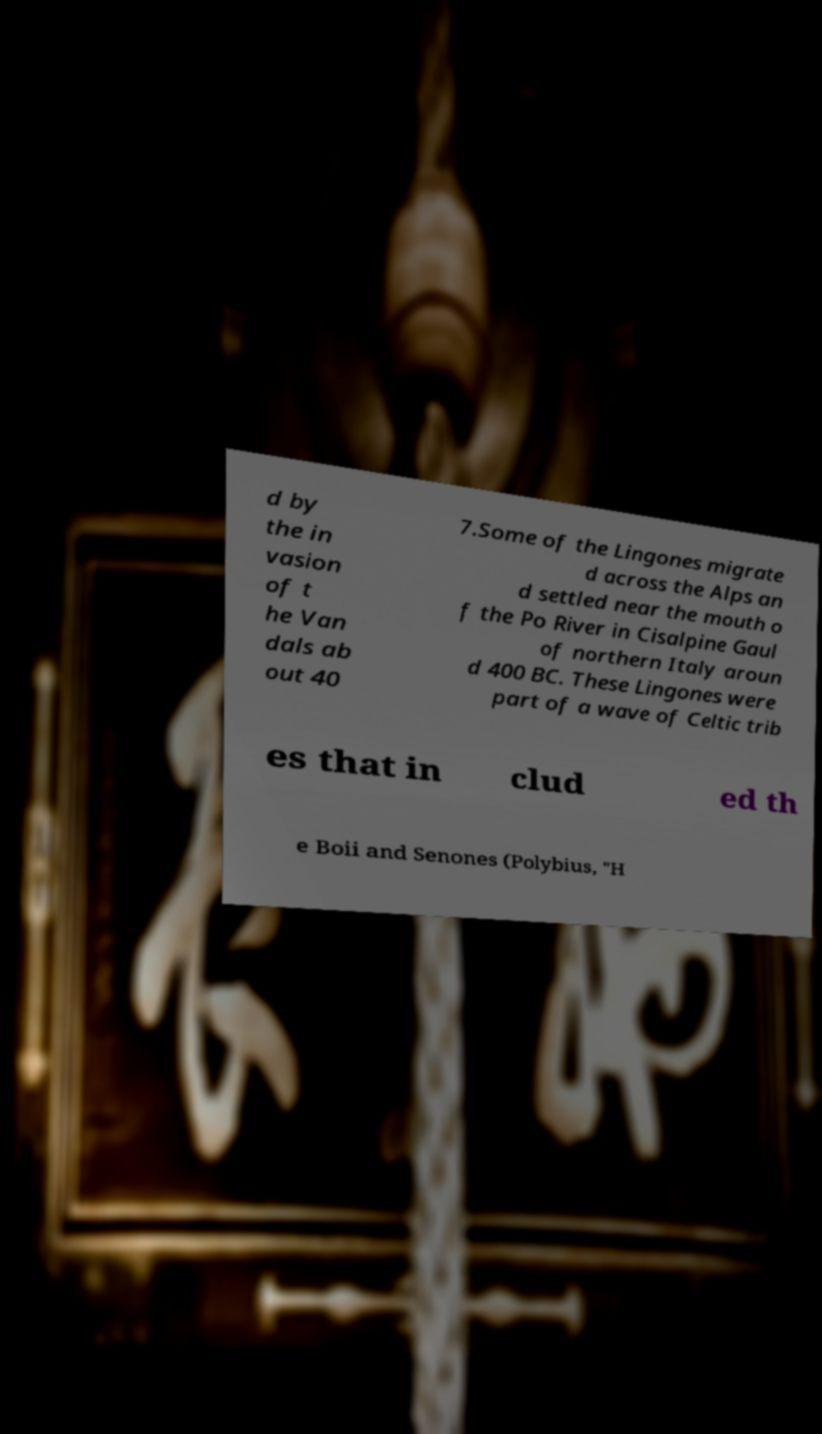Could you assist in decoding the text presented in this image and type it out clearly? d by the in vasion of t he Van dals ab out 40 7.Some of the Lingones migrate d across the Alps an d settled near the mouth o f the Po River in Cisalpine Gaul of northern Italy aroun d 400 BC. These Lingones were part of a wave of Celtic trib es that in clud ed th e Boii and Senones (Polybius, "H 